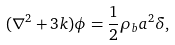Convert formula to latex. <formula><loc_0><loc_0><loc_500><loc_500>( { \nabla } ^ { 2 } + 3 k ) \phi = \frac { 1 } { 2 } { \rho } _ { b } a ^ { 2 } \delta ,</formula> 